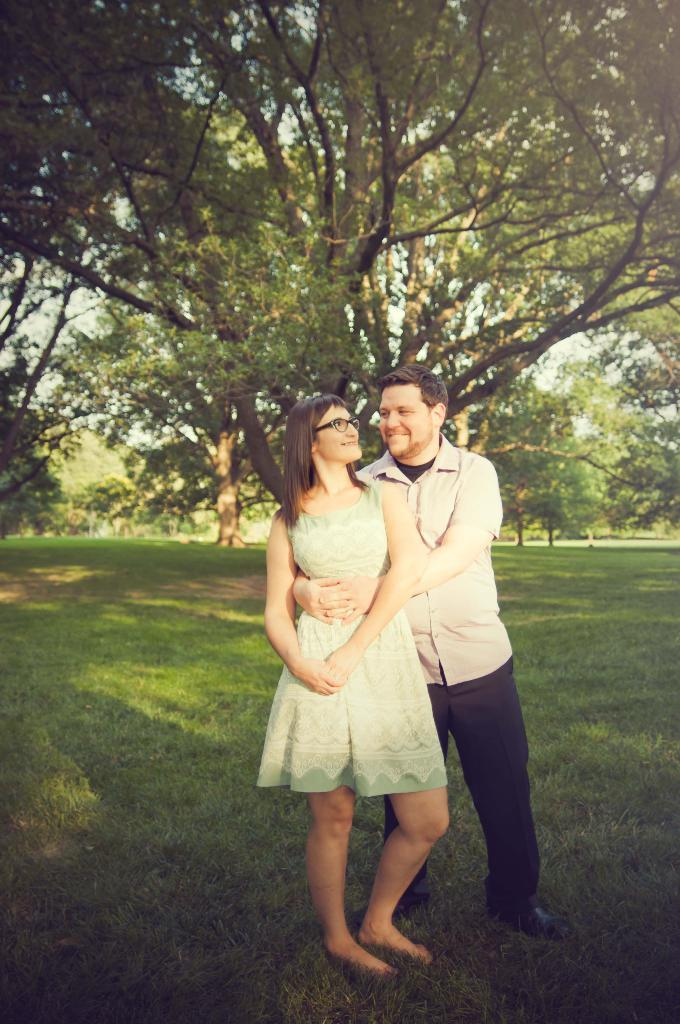Who is present in the image? There is a couple in the image. What are the couple doing in the image? The couple is standing and posing for the picture. What can be seen in the background of the image? There are trees visible in the image. Where are the trees located? The trees are located in a garden. What type of brush is the couple using to paint the trees in the image? There is no brush present in the image, and the couple is not painting the trees. Can you recite the verse that the couple is saying in the image? There is no verse being spoken by the couple in the image. 